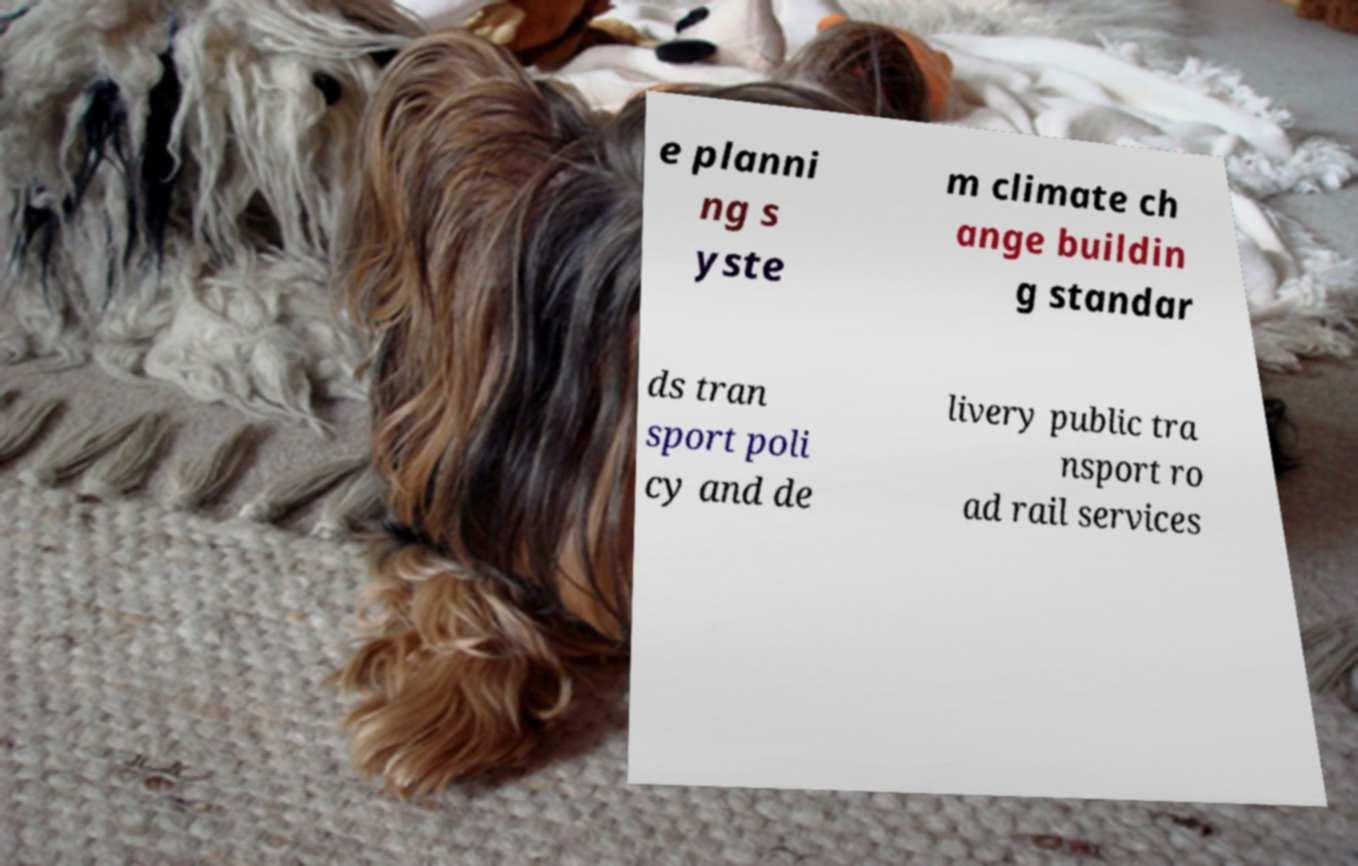For documentation purposes, I need the text within this image transcribed. Could you provide that? e planni ng s yste m climate ch ange buildin g standar ds tran sport poli cy and de livery public tra nsport ro ad rail services 